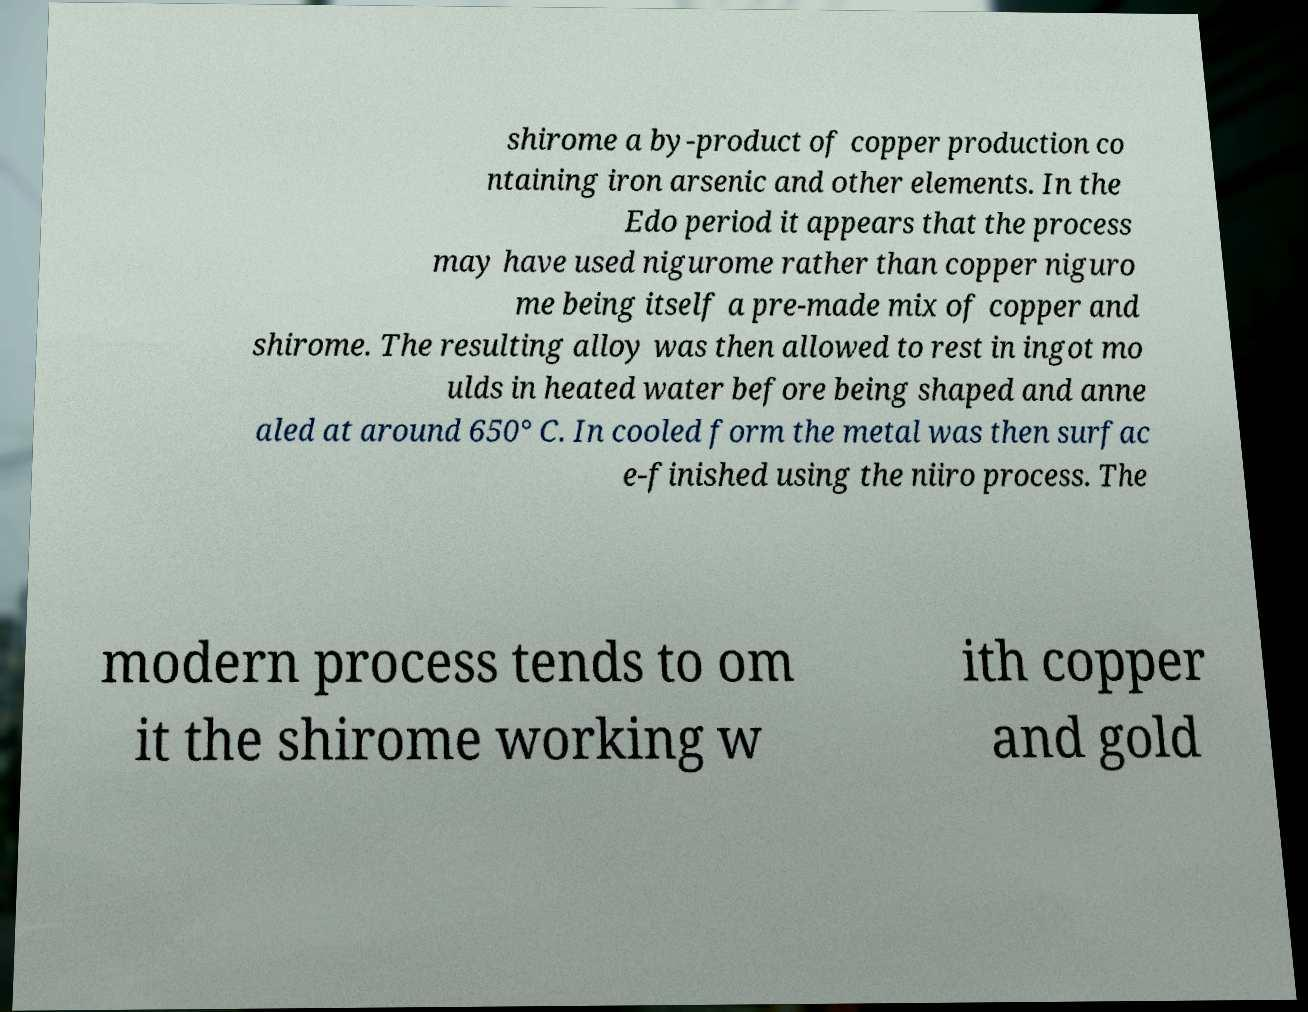Can you read and provide the text displayed in the image?This photo seems to have some interesting text. Can you extract and type it out for me? shirome a by-product of copper production co ntaining iron arsenic and other elements. In the Edo period it appears that the process may have used nigurome rather than copper niguro me being itself a pre-made mix of copper and shirome. The resulting alloy was then allowed to rest in ingot mo ulds in heated water before being shaped and anne aled at around 650° C. In cooled form the metal was then surfac e-finished using the niiro process. The modern process tends to om it the shirome working w ith copper and gold 